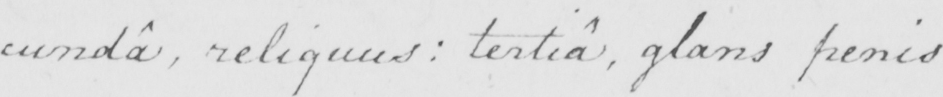What does this handwritten line say? : cunda , reliquus :  tertia , glans penis : 